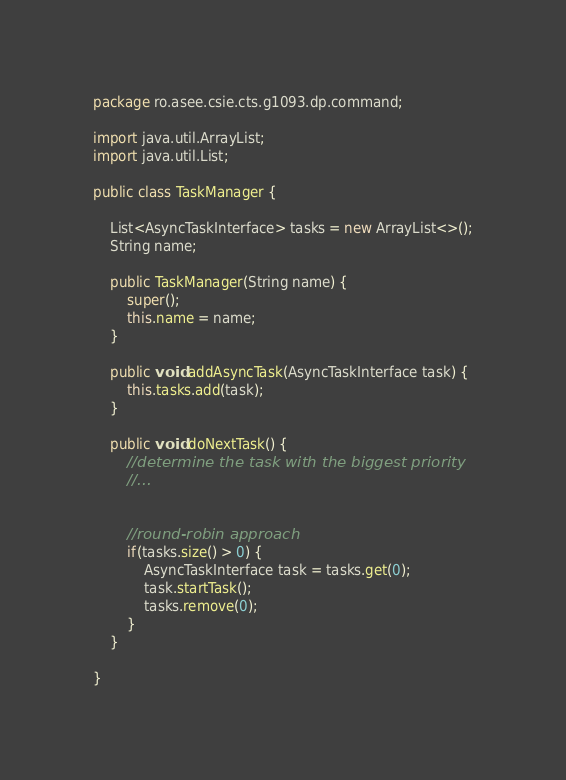Convert code to text. <code><loc_0><loc_0><loc_500><loc_500><_Java_>package ro.asee.csie.cts.g1093.dp.command;

import java.util.ArrayList;
import java.util.List;

public class TaskManager {
	
	List<AsyncTaskInterface> tasks = new ArrayList<>();
	String name;
	
	public TaskManager(String name) {
		super();
		this.name = name;
	}
	
	public void addAsyncTask(AsyncTaskInterface task) {
		this.tasks.add(task);
	}
	
	public void doNextTask() {
		//determine the task with the biggest priority
		//...
		
		
		//round-robin approach
		if(tasks.size() > 0) {
			AsyncTaskInterface task = tasks.get(0);
			task.startTask();
			tasks.remove(0);
		}
	}
	
}
</code> 